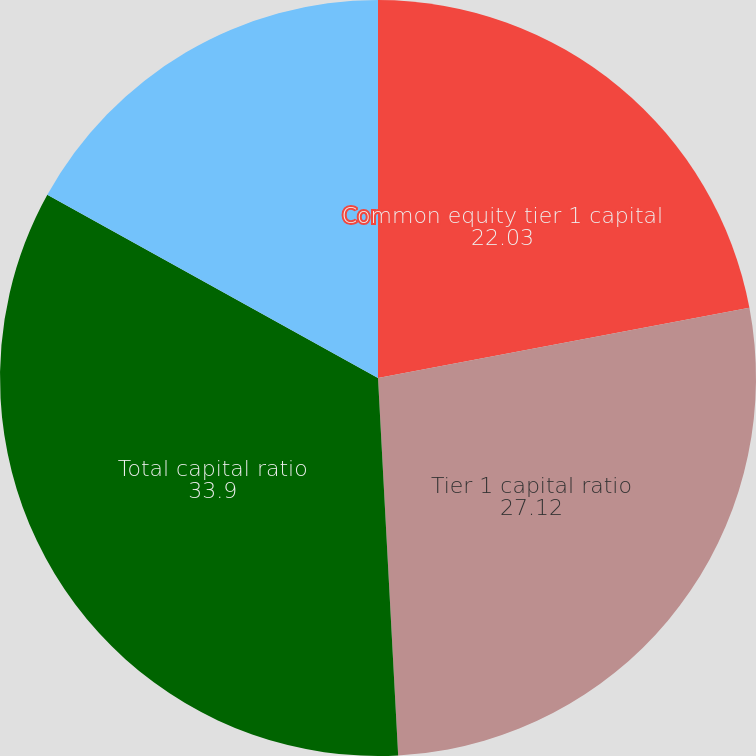Convert chart to OTSL. <chart><loc_0><loc_0><loc_500><loc_500><pie_chart><fcel>Common equity tier 1 capital<fcel>Tier 1 capital ratio<fcel>Total capital ratio<fcel>Tier 1 leverage ratio<nl><fcel>22.03%<fcel>27.12%<fcel>33.9%<fcel>16.95%<nl></chart> 